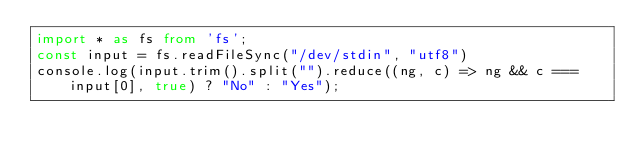Convert code to text. <code><loc_0><loc_0><loc_500><loc_500><_TypeScript_>import * as fs from 'fs';
const input = fs.readFileSync("/dev/stdin", "utf8")
console.log(input.trim().split("").reduce((ng, c) => ng && c === input[0], true) ? "No" : "Yes");</code> 